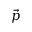<formula> <loc_0><loc_0><loc_500><loc_500>\vec { p }</formula> 